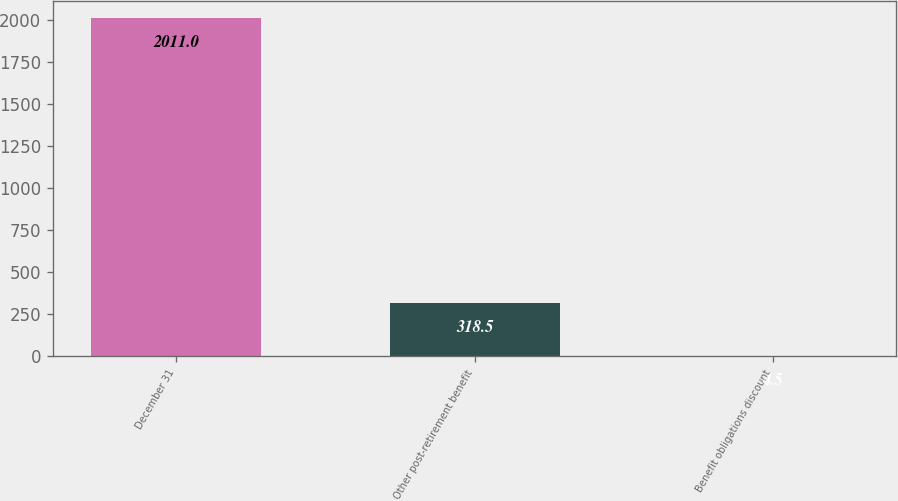Convert chart to OTSL. <chart><loc_0><loc_0><loc_500><loc_500><bar_chart><fcel>December 31<fcel>Other post-retirement benefit<fcel>Benefit obligations discount<nl><fcel>2011<fcel>318.5<fcel>4.5<nl></chart> 